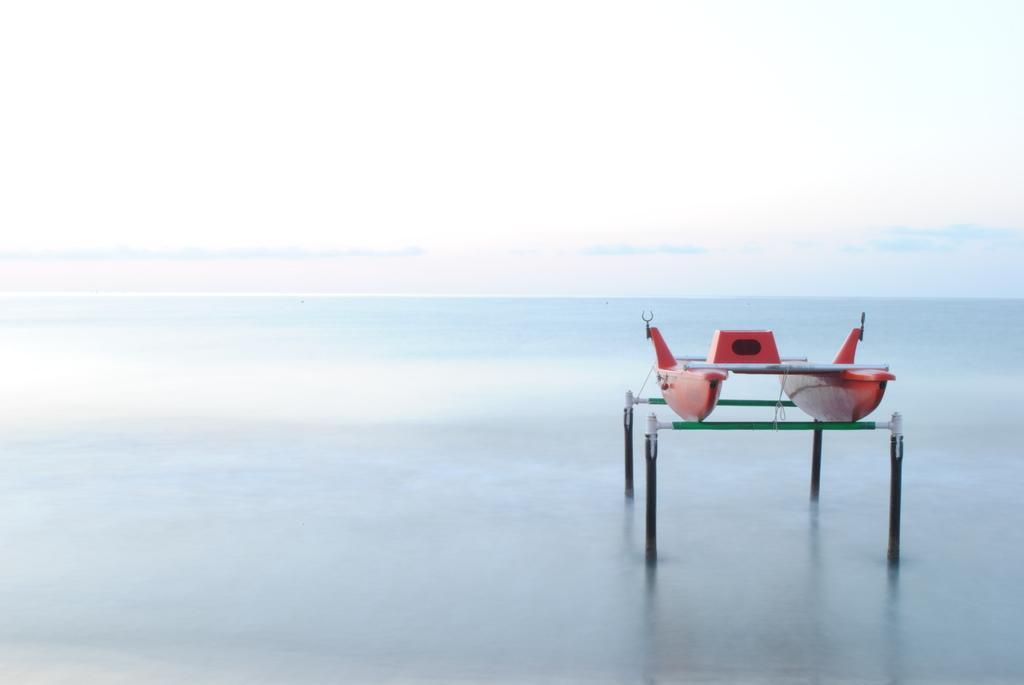Could you give a brief overview of what you see in this image? In the front of the image there is a boat, rods and water. In the background of the image there is the sky.   